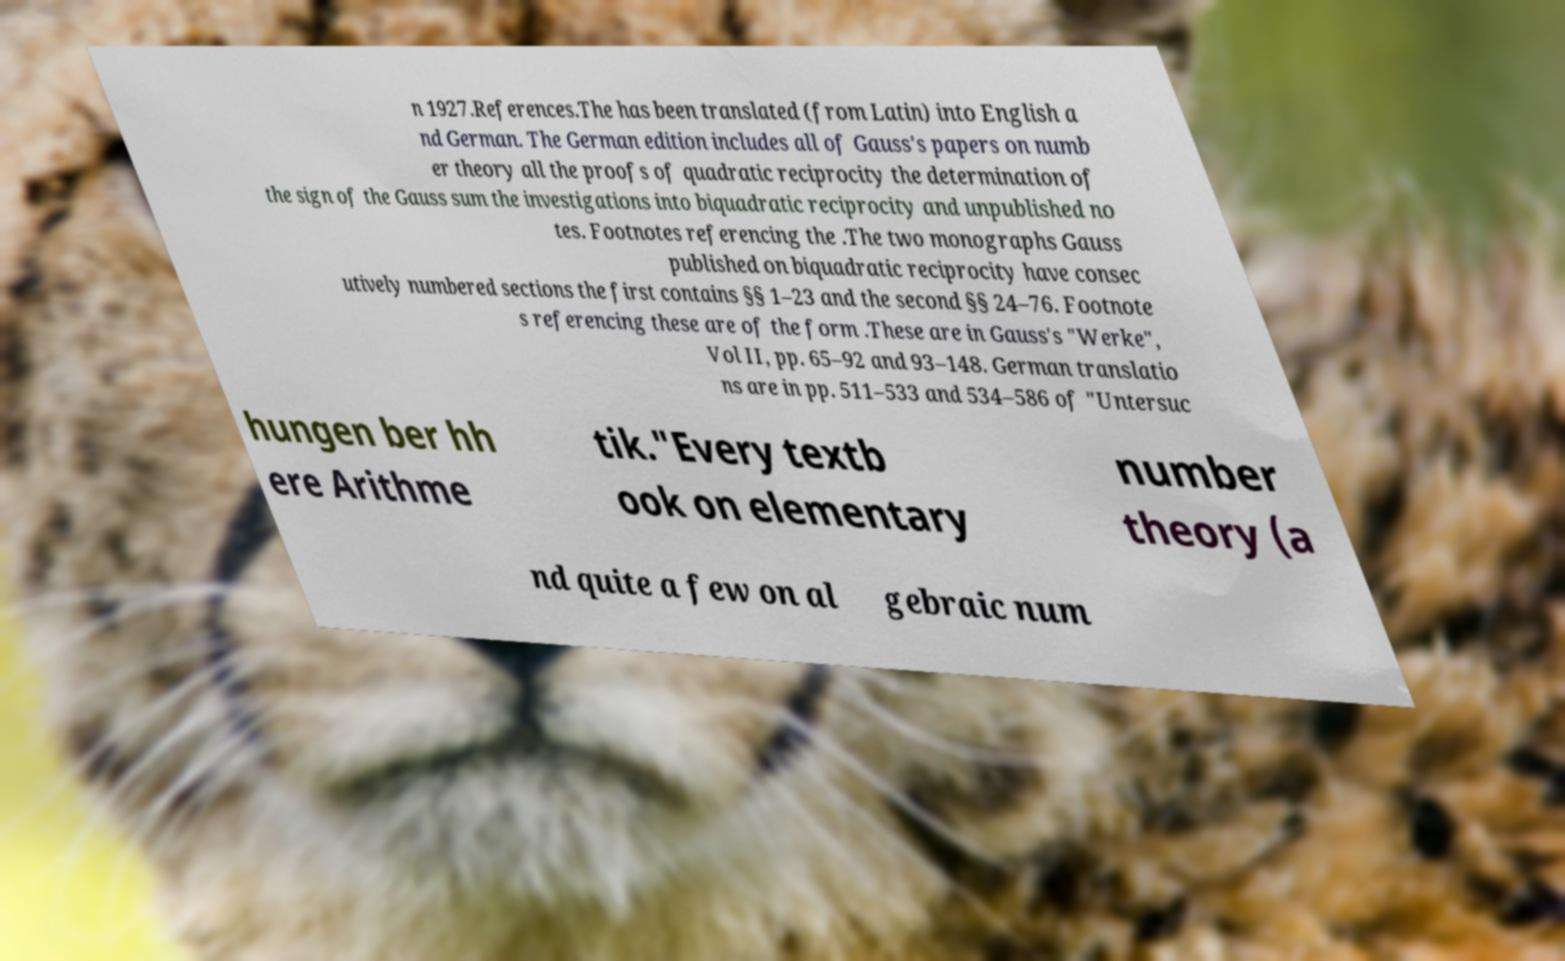Can you accurately transcribe the text from the provided image for me? n 1927.References.The has been translated (from Latin) into English a nd German. The German edition includes all of Gauss's papers on numb er theory all the proofs of quadratic reciprocity the determination of the sign of the Gauss sum the investigations into biquadratic reciprocity and unpublished no tes. Footnotes referencing the .The two monographs Gauss published on biquadratic reciprocity have consec utively numbered sections the first contains §§ 1–23 and the second §§ 24–76. Footnote s referencing these are of the form .These are in Gauss's "Werke", Vol II, pp. 65–92 and 93–148. German translatio ns are in pp. 511–533 and 534–586 of "Untersuc hungen ber hh ere Arithme tik."Every textb ook on elementary number theory (a nd quite a few on al gebraic num 